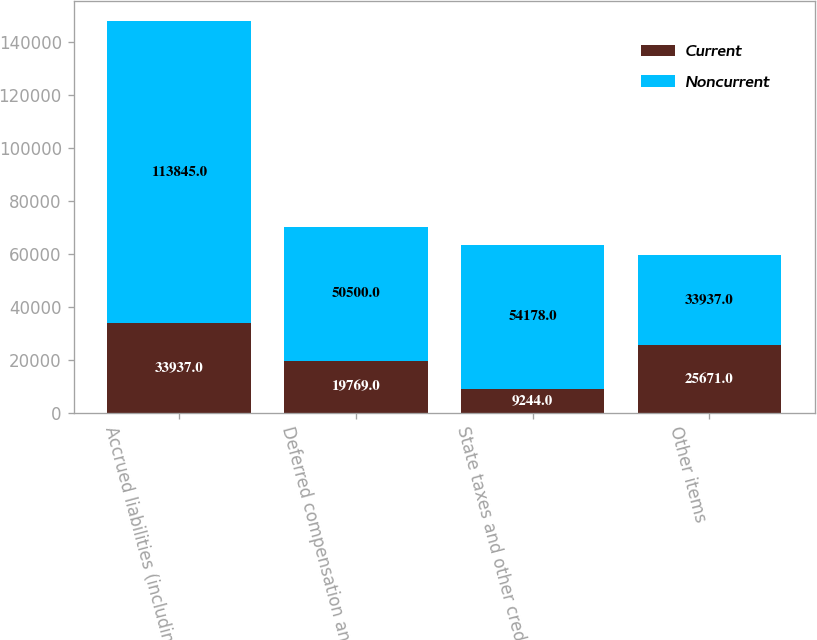Convert chart to OTSL. <chart><loc_0><loc_0><loc_500><loc_500><stacked_bar_chart><ecel><fcel>Accrued liabilities (including<fcel>Deferred compensation and<fcel>State taxes and other credits<fcel>Other items<nl><fcel>Current<fcel>33937<fcel>19769<fcel>9244<fcel>25671<nl><fcel>Noncurrent<fcel>113845<fcel>50500<fcel>54178<fcel>33937<nl></chart> 